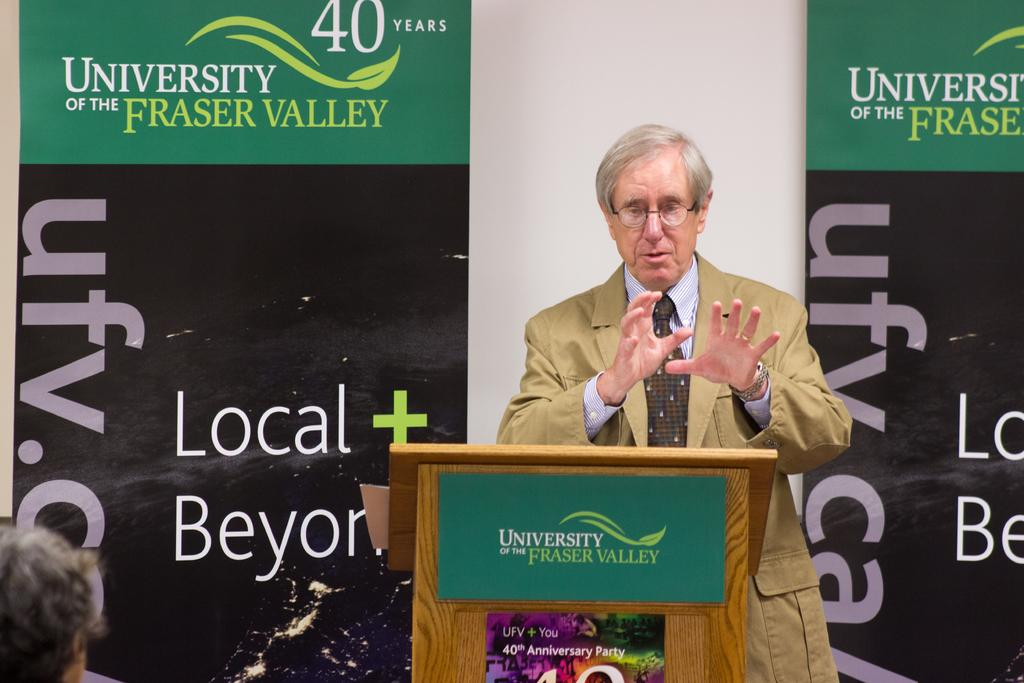What is the man in the image doing? The man is standing behind a podium in the image. What can be seen behind the man? There are banners behind the man, and a wall behind the banners. Can you describe the person's head visible in front of the podium? There is a person's head visible in front of the podium, but no other details are provided. What type of nerve can be seen stimulating the bee in the image? There is no nerve or bee present in the image. 